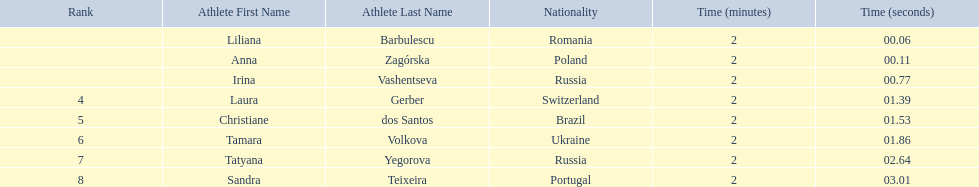Who were all of the athletes? Liliana Barbulescu, Anna Zagórska, Irina Vashentseva, Laura Gerber, Christiane dos Santos, Tamara Volkova, Tatyana Yegorova, Sandra Teixeira. What were their finishing times? 2:00.06, 2:00.11, 2:00.77, 2:01.39, 2:01.53, 2:01.86, 2:02.64, 2:03.01. Which athlete finished earliest? Liliana Barbulescu. 